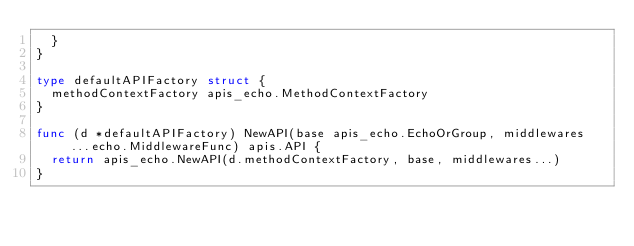<code> <loc_0><loc_0><loc_500><loc_500><_Go_>	}
}

type defaultAPIFactory struct {
	methodContextFactory apis_echo.MethodContextFactory
}

func (d *defaultAPIFactory) NewAPI(base apis_echo.EchoOrGroup, middlewares ...echo.MiddlewareFunc) apis.API {
	return apis_echo.NewAPI(d.methodContextFactory, base, middlewares...)
}
</code> 